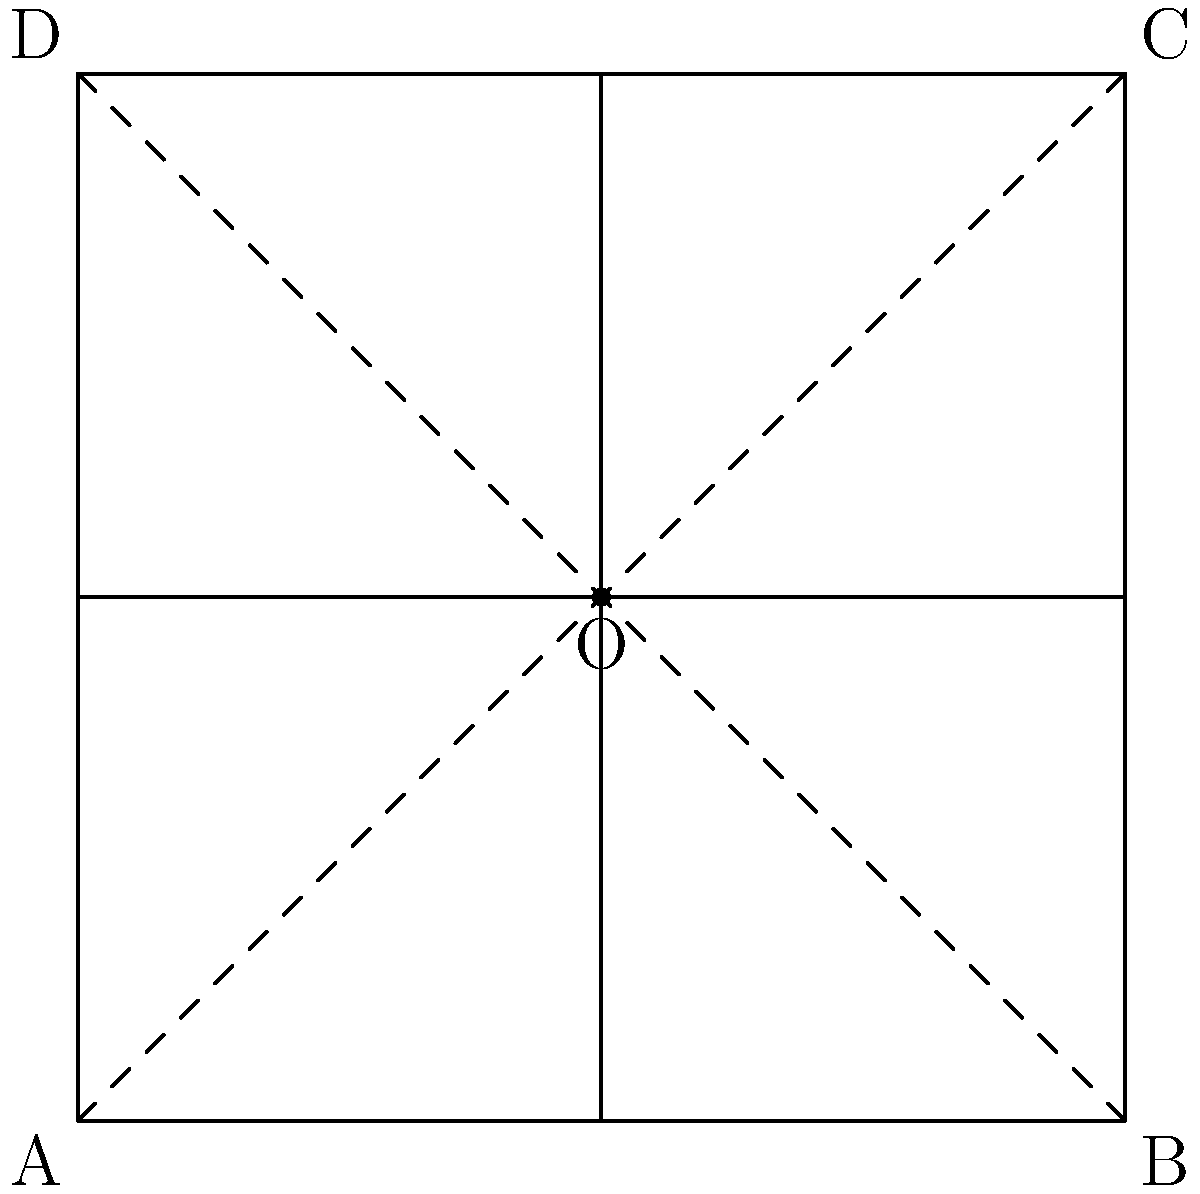In a standard soccer field, the diagonal lines intersect at the center point O. If the field dimensions are 100 meters by 100 meters (for simplicity), what is the measure of the angle formed by these two intersecting diagonal lines? Let's approach this step-by-step:

1) The soccer field is represented as a square ABCD with side length 100 meters.

2) The diagonals AC and BD intersect at point O, the center of the square.

3) In a square, the diagonals are perpendicular to each other. This means they form four right angles at the point of intersection.

4) A right angle measures 90°.

5) Since the diagonals are perpendicular, they divide the 360° around point O into four equal parts.

6) Therefore, the angle formed by the two intersecting diagonal lines is:

   $$360° ÷ 4 = 90°$$

This 90° angle is consistent with the perpendicular nature of diagonals in a square, which is maintained regardless of the actual dimensions of the soccer field.
Answer: 90° 